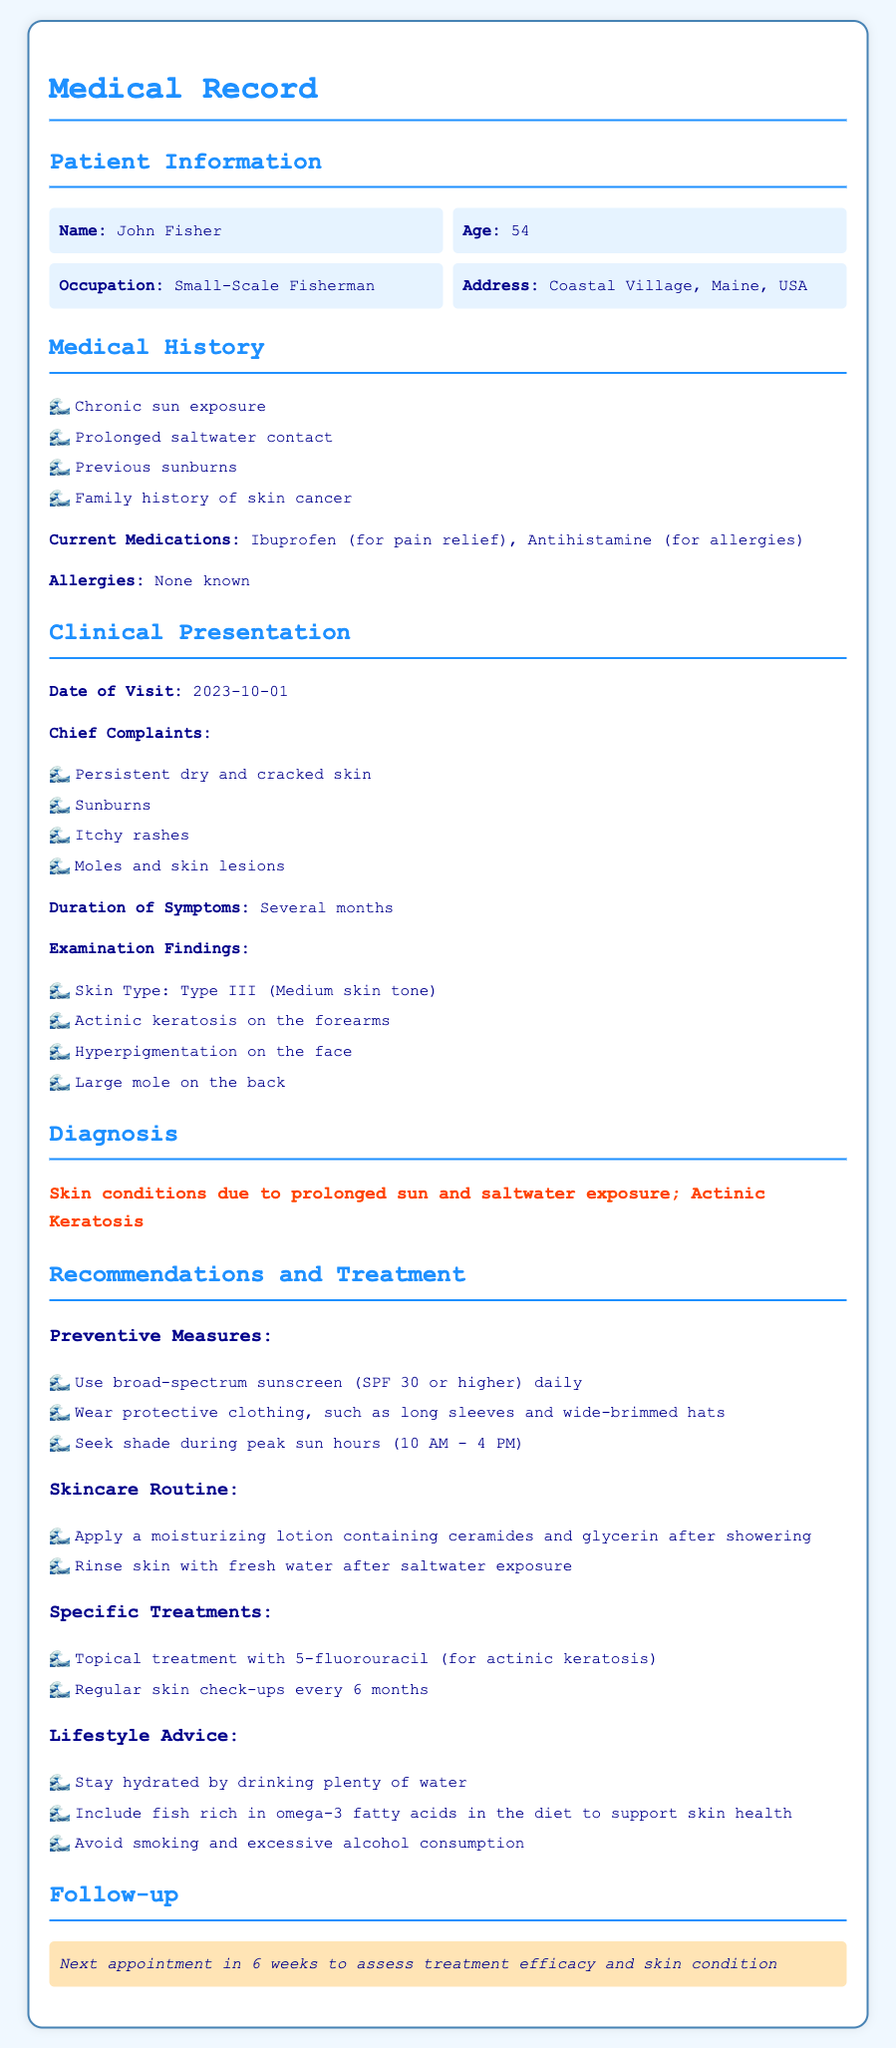What is the patient's name? The patient's name is found in the patient information section.
Answer: John Fisher What is the patient's age? The patient's age is also in the patient information section.
Answer: 54 What skin condition was diagnosed? The diagnosis section specifies the skin condition affecting the patient.
Answer: Skin conditions due to prolonged sun and saltwater exposure; Actinic Keratosis What is one of the recommendations for preventive measures? The recommendations and treatment section lists preventive measures for skin conditions.
Answer: Use broad-spectrum sunscreen (SPF 30 or higher) daily What is the date of the patient's visit? The date of visit is mentioned in the clinical presentation section.
Answer: 2023-10-01 How often should skin check-ups occur? The recommendations mention a specific frequency for skin check-ups.
Answer: Every 6 months What type of skin does the patient have? The examination findings in the clinical presentation provide the patient's skin type.
Answer: Type III (Medium skin tone) What should the patient avoid to support skin health? The lifestyle advice section outlines specific habits to avoid for better skin health.
Answer: Smoking and excessive alcohol consumption What is the next appointment duration? The follow-up section specifies when the next appointment should occur.
Answer: 6 weeks 